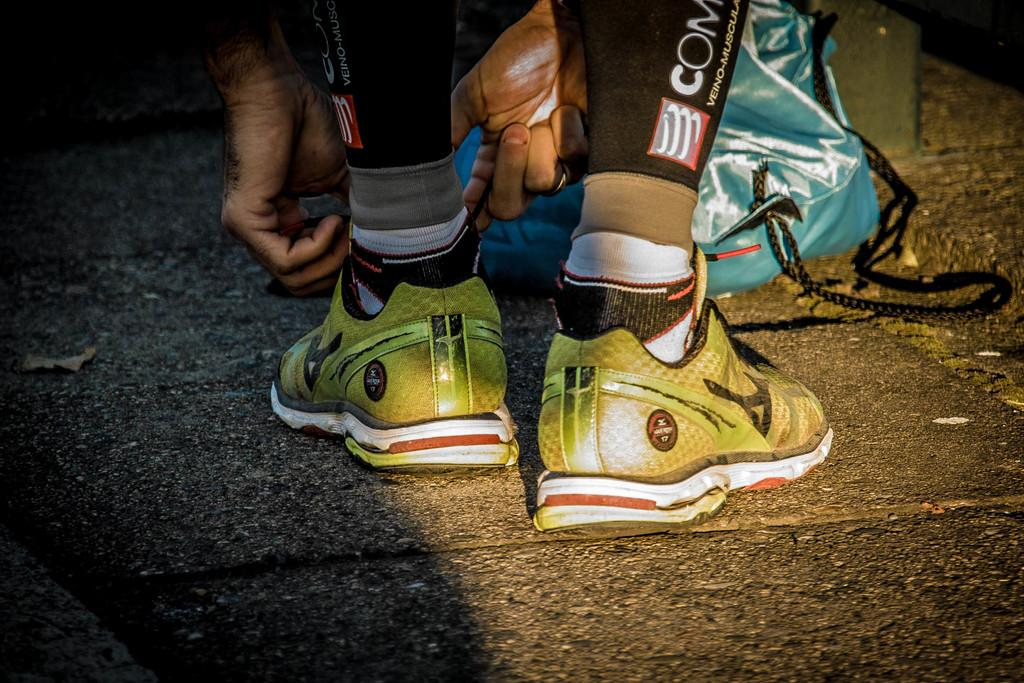Who is present in the image? There is a person in the image. What type of footwear is the person wearing? The person is wearing shoes and socks. What can be seen besides the person in the image? There is a blue and black color bag in the image. What is the color of the surface the bag is on? The bag is on an ash color surface. What statement does the person make in the image? There is no statement made by the person in the image. What type of flooring is visible in the image? The provided facts do not mention the flooring in the image. 